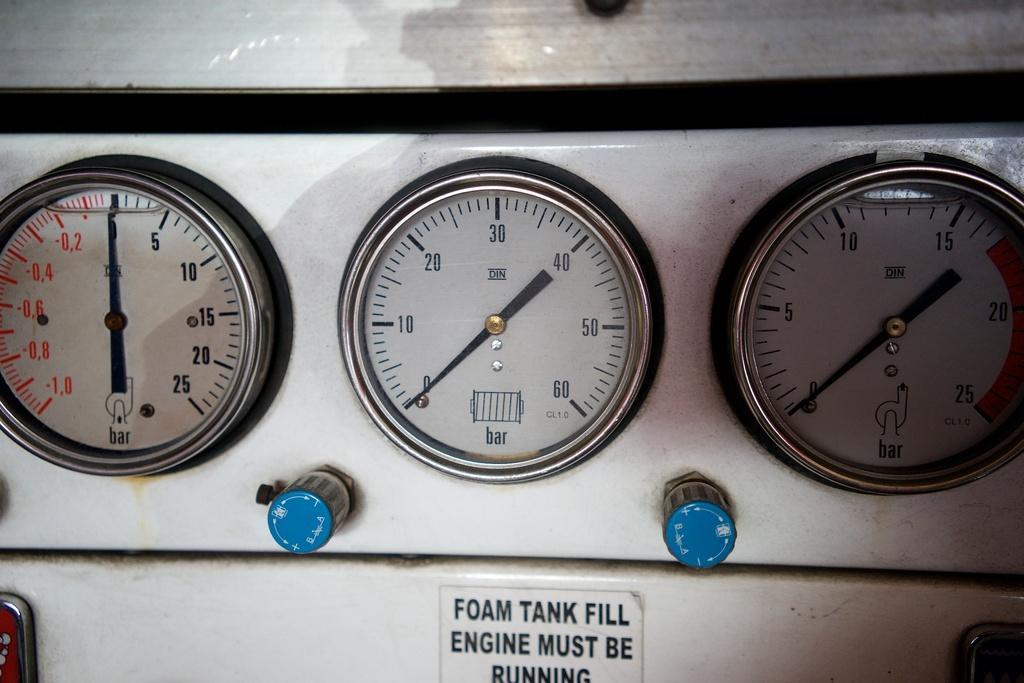Could you give a brief overview of what you see in this image? In this image I can see meter's, blue color objects and something written on the surface. 